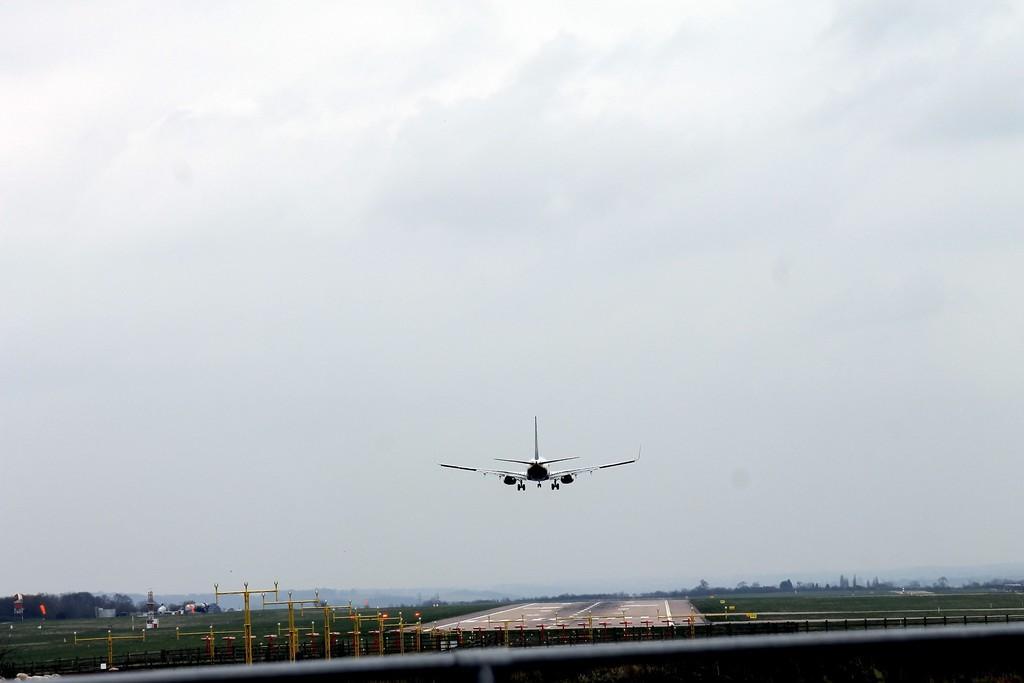Please provide a concise description of this image. In this picture I can observe an airplane flying in the air. In the bottom of the picture I can observe runway. In the background there is sky. 